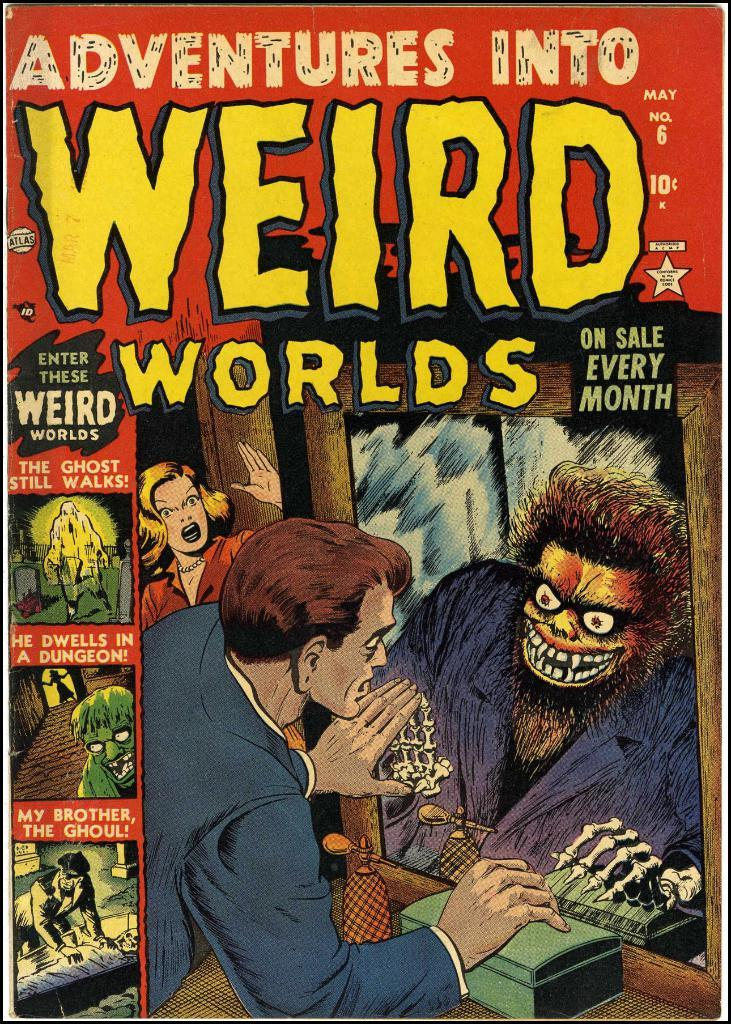What is the main subject of the image? The main subject of the image is a book. What type of content is featured in the book? The book contains photographs. Can you describe one of the photographs in the book? In one of the photographs, a man is looking into a mirror. What is unusual about the mirror in the photograph? There is a ghost in the mirror in the photograph. Are there any other people present in the photograph? Yes, a woman is present in the photograph on the left side. What type of tray is being used by the judge in the image? There is no tray or judge present in the image; it features a book with photographs. 